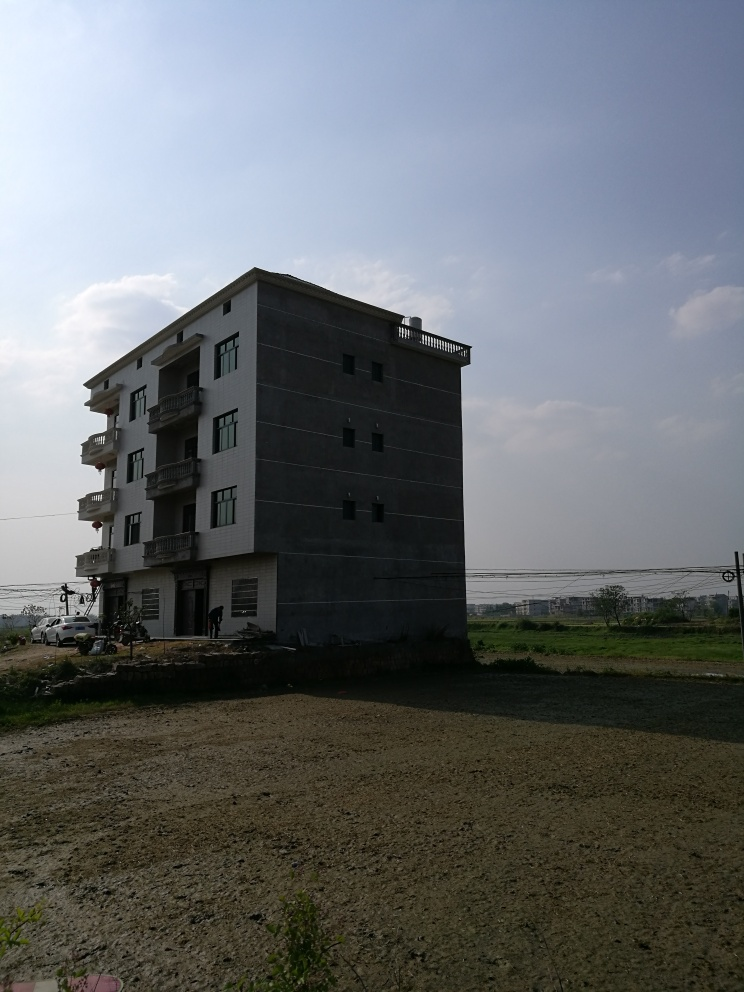What style or architectural features can you describe from the house in the image? The house displays a modern architectural style with a simple and functional design. It features a flat roof, symmetrically placed balcony areas, and a uniform color scheme. The building lacks traditional decorative elements and stands out for its minimalist aesthetic. Does the house appear to be new or old? Based on the clean lines and the lack of weathering or discoloration on the facade, the house seems to be relatively new or well-maintained. 